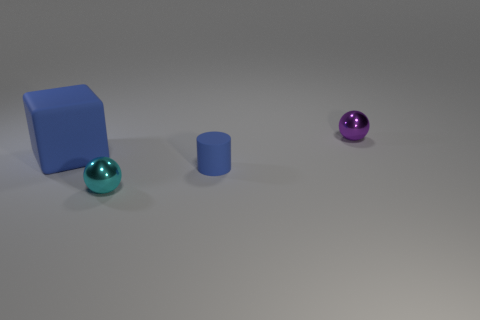Add 3 green rubber cylinders. How many objects exist? 7 Subtract all blocks. How many objects are left? 3 Add 2 large blue objects. How many large blue objects are left? 3 Add 3 small purple shiny objects. How many small purple shiny objects exist? 4 Subtract 0 yellow blocks. How many objects are left? 4 Subtract all cyan metallic spheres. Subtract all purple metal balls. How many objects are left? 2 